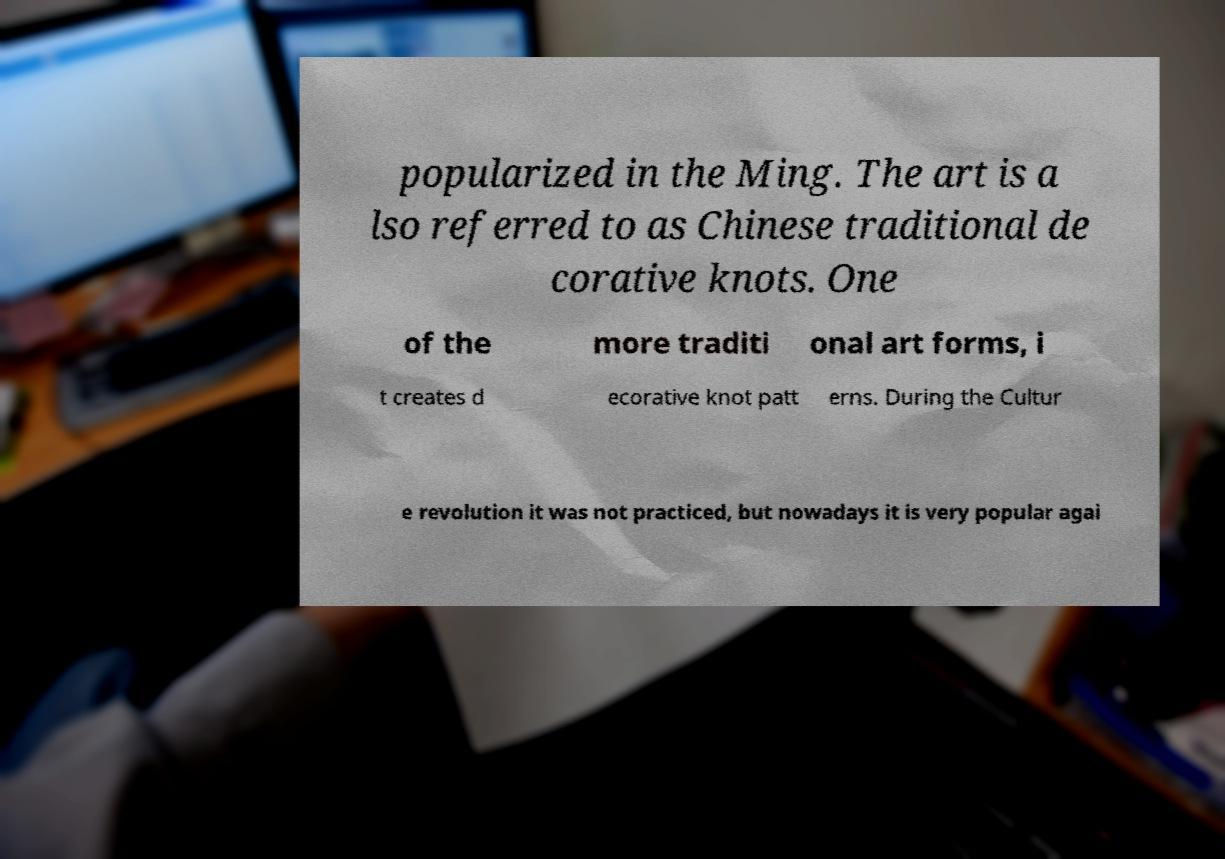There's text embedded in this image that I need extracted. Can you transcribe it verbatim? popularized in the Ming. The art is a lso referred to as Chinese traditional de corative knots. One of the more traditi onal art forms, i t creates d ecorative knot patt erns. During the Cultur e revolution it was not practiced, but nowadays it is very popular agai 